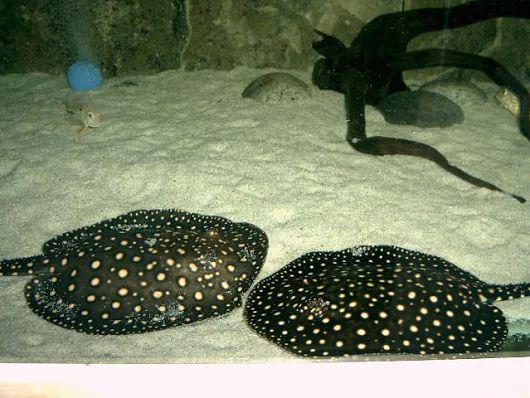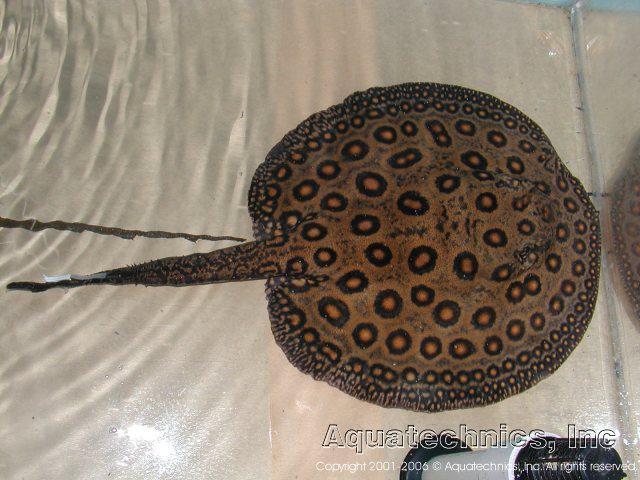The first image is the image on the left, the second image is the image on the right. Assess this claim about the two images: "No more than 2 animals in any of the pictures". Correct or not? Answer yes or no. Yes. The first image is the image on the left, the second image is the image on the right. Considering the images on both sides, is "there are 3 stingrays in the image pair" valid? Answer yes or no. Yes. 